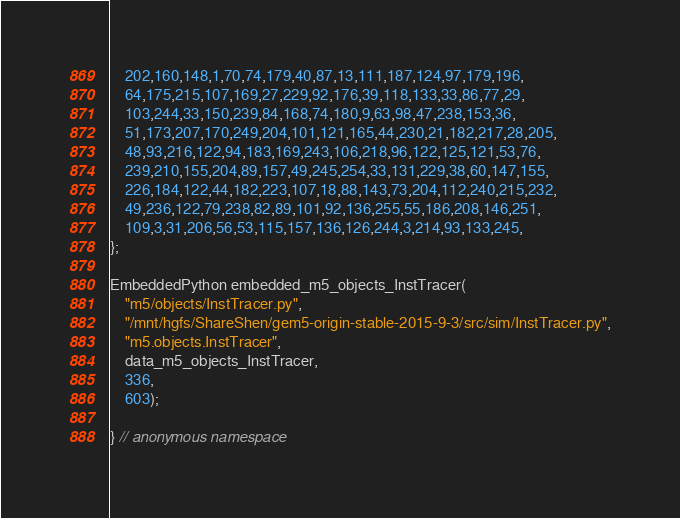Convert code to text. <code><loc_0><loc_0><loc_500><loc_500><_C++_>    202,160,148,1,70,74,179,40,87,13,111,187,124,97,179,196,
    64,175,215,107,169,27,229,92,176,39,118,133,33,86,77,29,
    103,244,33,150,239,84,168,74,180,9,63,98,47,238,153,36,
    51,173,207,170,249,204,101,121,165,44,230,21,182,217,28,205,
    48,93,216,122,94,183,169,243,106,218,96,122,125,121,53,76,
    239,210,155,204,89,157,49,245,254,33,131,229,38,60,147,155,
    226,184,122,44,182,223,107,18,88,143,73,204,112,240,215,232,
    49,236,122,79,238,82,89,101,92,136,255,55,186,208,146,251,
    109,3,31,206,56,53,115,157,136,126,244,3,214,93,133,245,
};

EmbeddedPython embedded_m5_objects_InstTracer(
    "m5/objects/InstTracer.py",
    "/mnt/hgfs/ShareShen/gem5-origin-stable-2015-9-3/src/sim/InstTracer.py",
    "m5.objects.InstTracer",
    data_m5_objects_InstTracer,
    336,
    603);

} // anonymous namespace
</code> 